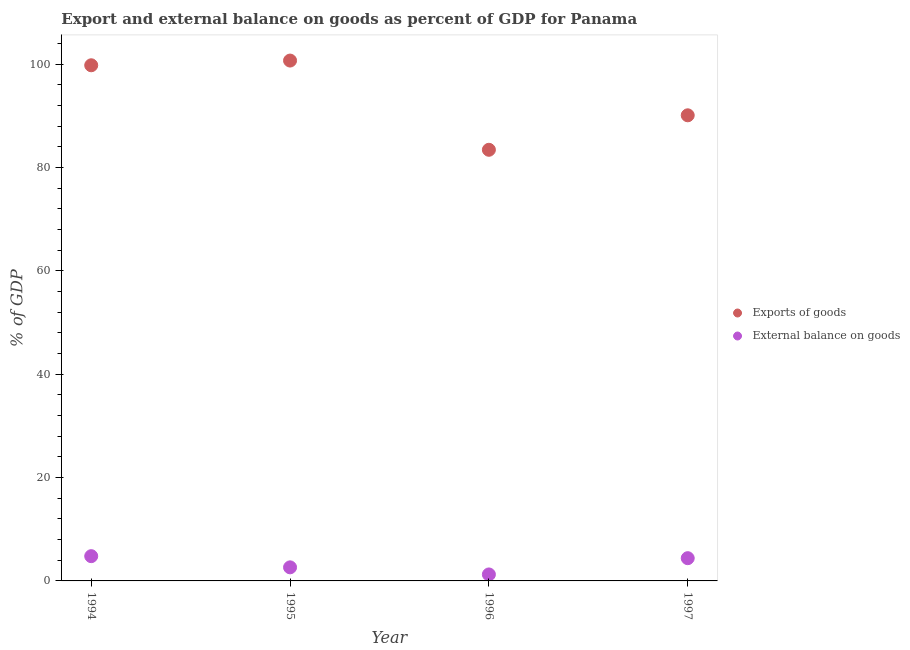How many different coloured dotlines are there?
Keep it short and to the point. 2. What is the export of goods as percentage of gdp in 1997?
Your response must be concise. 90.11. Across all years, what is the maximum export of goods as percentage of gdp?
Offer a terse response. 100.7. Across all years, what is the minimum external balance on goods as percentage of gdp?
Offer a terse response. 1.25. In which year was the external balance on goods as percentage of gdp maximum?
Your answer should be very brief. 1994. In which year was the export of goods as percentage of gdp minimum?
Keep it short and to the point. 1996. What is the total external balance on goods as percentage of gdp in the graph?
Your answer should be very brief. 13.07. What is the difference between the external balance on goods as percentage of gdp in 1995 and that in 1997?
Make the answer very short. -1.77. What is the difference between the export of goods as percentage of gdp in 1997 and the external balance on goods as percentage of gdp in 1995?
Your answer should be very brief. 87.48. What is the average export of goods as percentage of gdp per year?
Provide a short and direct response. 93.5. In the year 1996, what is the difference between the external balance on goods as percentage of gdp and export of goods as percentage of gdp?
Ensure brevity in your answer.  -82.18. What is the ratio of the external balance on goods as percentage of gdp in 1994 to that in 1996?
Provide a succinct answer. 3.82. Is the difference between the external balance on goods as percentage of gdp in 1995 and 1996 greater than the difference between the export of goods as percentage of gdp in 1995 and 1996?
Provide a succinct answer. No. What is the difference between the highest and the second highest export of goods as percentage of gdp?
Your answer should be compact. 0.91. What is the difference between the highest and the lowest export of goods as percentage of gdp?
Give a very brief answer. 17.27. Is the sum of the external balance on goods as percentage of gdp in 1994 and 1997 greater than the maximum export of goods as percentage of gdp across all years?
Your answer should be compact. No. Is the export of goods as percentage of gdp strictly greater than the external balance on goods as percentage of gdp over the years?
Your response must be concise. Yes. Is the external balance on goods as percentage of gdp strictly less than the export of goods as percentage of gdp over the years?
Keep it short and to the point. Yes. How many dotlines are there?
Give a very brief answer. 2. How many years are there in the graph?
Make the answer very short. 4. Are the values on the major ticks of Y-axis written in scientific E-notation?
Provide a succinct answer. No. How are the legend labels stacked?
Offer a terse response. Vertical. What is the title of the graph?
Give a very brief answer. Export and external balance on goods as percent of GDP for Panama. What is the label or title of the Y-axis?
Your response must be concise. % of GDP. What is the % of GDP in Exports of goods in 1994?
Offer a terse response. 99.79. What is the % of GDP in External balance on goods in 1994?
Make the answer very short. 4.79. What is the % of GDP of Exports of goods in 1995?
Your answer should be very brief. 100.7. What is the % of GDP in External balance on goods in 1995?
Your answer should be very brief. 2.63. What is the % of GDP of Exports of goods in 1996?
Provide a succinct answer. 83.43. What is the % of GDP in External balance on goods in 1996?
Your answer should be compact. 1.25. What is the % of GDP in Exports of goods in 1997?
Give a very brief answer. 90.11. What is the % of GDP in External balance on goods in 1997?
Offer a terse response. 4.4. Across all years, what is the maximum % of GDP of Exports of goods?
Provide a short and direct response. 100.7. Across all years, what is the maximum % of GDP of External balance on goods?
Ensure brevity in your answer.  4.79. Across all years, what is the minimum % of GDP in Exports of goods?
Provide a short and direct response. 83.43. Across all years, what is the minimum % of GDP in External balance on goods?
Your answer should be compact. 1.25. What is the total % of GDP in Exports of goods in the graph?
Your answer should be compact. 374.02. What is the total % of GDP of External balance on goods in the graph?
Provide a succinct answer. 13.07. What is the difference between the % of GDP of Exports of goods in 1994 and that in 1995?
Ensure brevity in your answer.  -0.91. What is the difference between the % of GDP in External balance on goods in 1994 and that in 1995?
Offer a terse response. 2.16. What is the difference between the % of GDP in Exports of goods in 1994 and that in 1996?
Offer a very short reply. 16.35. What is the difference between the % of GDP in External balance on goods in 1994 and that in 1996?
Ensure brevity in your answer.  3.54. What is the difference between the % of GDP of Exports of goods in 1994 and that in 1997?
Your response must be concise. 9.68. What is the difference between the % of GDP in External balance on goods in 1994 and that in 1997?
Offer a very short reply. 0.39. What is the difference between the % of GDP in Exports of goods in 1995 and that in 1996?
Provide a short and direct response. 17.27. What is the difference between the % of GDP in External balance on goods in 1995 and that in 1996?
Your answer should be compact. 1.37. What is the difference between the % of GDP in Exports of goods in 1995 and that in 1997?
Keep it short and to the point. 10.59. What is the difference between the % of GDP in External balance on goods in 1995 and that in 1997?
Offer a very short reply. -1.77. What is the difference between the % of GDP of Exports of goods in 1996 and that in 1997?
Your response must be concise. -6.67. What is the difference between the % of GDP in External balance on goods in 1996 and that in 1997?
Give a very brief answer. -3.15. What is the difference between the % of GDP of Exports of goods in 1994 and the % of GDP of External balance on goods in 1995?
Your answer should be very brief. 97.16. What is the difference between the % of GDP in Exports of goods in 1994 and the % of GDP in External balance on goods in 1996?
Provide a short and direct response. 98.53. What is the difference between the % of GDP in Exports of goods in 1994 and the % of GDP in External balance on goods in 1997?
Offer a terse response. 95.39. What is the difference between the % of GDP of Exports of goods in 1995 and the % of GDP of External balance on goods in 1996?
Provide a succinct answer. 99.44. What is the difference between the % of GDP of Exports of goods in 1995 and the % of GDP of External balance on goods in 1997?
Make the answer very short. 96.3. What is the difference between the % of GDP of Exports of goods in 1996 and the % of GDP of External balance on goods in 1997?
Your answer should be compact. 79.03. What is the average % of GDP in Exports of goods per year?
Offer a terse response. 93.5. What is the average % of GDP of External balance on goods per year?
Make the answer very short. 3.27. In the year 1994, what is the difference between the % of GDP in Exports of goods and % of GDP in External balance on goods?
Your answer should be very brief. 94.99. In the year 1995, what is the difference between the % of GDP of Exports of goods and % of GDP of External balance on goods?
Keep it short and to the point. 98.07. In the year 1996, what is the difference between the % of GDP in Exports of goods and % of GDP in External balance on goods?
Keep it short and to the point. 82.18. In the year 1997, what is the difference between the % of GDP of Exports of goods and % of GDP of External balance on goods?
Offer a very short reply. 85.71. What is the ratio of the % of GDP of Exports of goods in 1994 to that in 1995?
Your answer should be compact. 0.99. What is the ratio of the % of GDP of External balance on goods in 1994 to that in 1995?
Keep it short and to the point. 1.82. What is the ratio of the % of GDP of Exports of goods in 1994 to that in 1996?
Your answer should be very brief. 1.2. What is the ratio of the % of GDP of External balance on goods in 1994 to that in 1996?
Your answer should be compact. 3.82. What is the ratio of the % of GDP in Exports of goods in 1994 to that in 1997?
Provide a succinct answer. 1.11. What is the ratio of the % of GDP in External balance on goods in 1994 to that in 1997?
Your answer should be very brief. 1.09. What is the ratio of the % of GDP in Exports of goods in 1995 to that in 1996?
Ensure brevity in your answer.  1.21. What is the ratio of the % of GDP in External balance on goods in 1995 to that in 1996?
Ensure brevity in your answer.  2.09. What is the ratio of the % of GDP in Exports of goods in 1995 to that in 1997?
Offer a very short reply. 1.12. What is the ratio of the % of GDP of External balance on goods in 1995 to that in 1997?
Your answer should be very brief. 0.6. What is the ratio of the % of GDP of Exports of goods in 1996 to that in 1997?
Make the answer very short. 0.93. What is the ratio of the % of GDP of External balance on goods in 1996 to that in 1997?
Provide a succinct answer. 0.28. What is the difference between the highest and the second highest % of GDP in Exports of goods?
Make the answer very short. 0.91. What is the difference between the highest and the second highest % of GDP in External balance on goods?
Give a very brief answer. 0.39. What is the difference between the highest and the lowest % of GDP in Exports of goods?
Give a very brief answer. 17.27. What is the difference between the highest and the lowest % of GDP of External balance on goods?
Give a very brief answer. 3.54. 